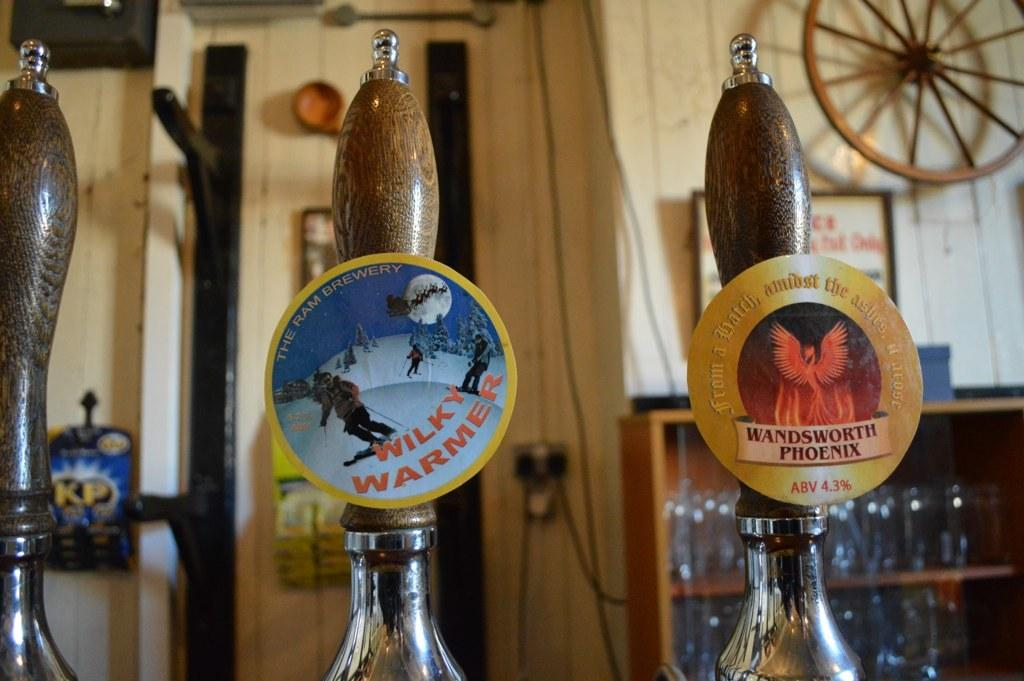<image>
Create a compact narrative representing the image presented. Wilky warmer and  wandsworth phoenix labels on a bottle 